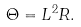Convert formula to latex. <formula><loc_0><loc_0><loc_500><loc_500>\Theta = L ^ { 2 } R .</formula> 